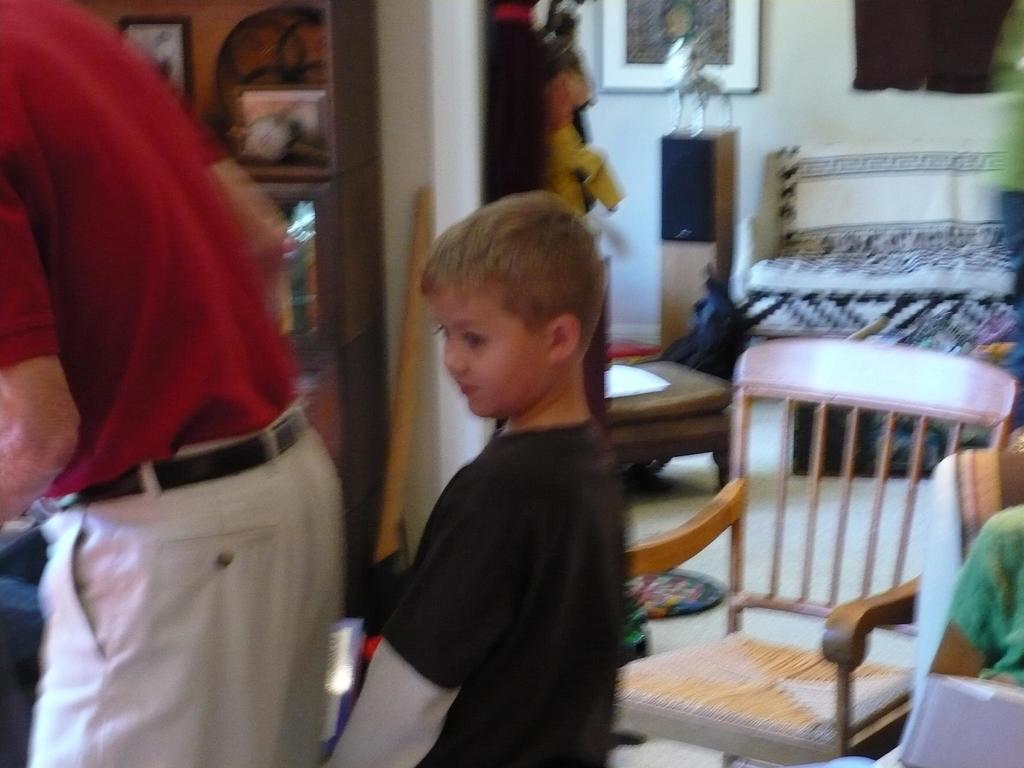Who is standing on the left side of the image? There is a person standing on the left side of the image. Who is standing in the center of the image? There is a boy standing in the center of the image. What objects can be seen in the background of the image? There is a chair and a bed in the background of the image. What type of low spring is visible in the image? There is no low spring present in the image. 